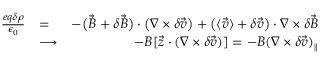Convert formula to latex. <formula><loc_0><loc_0><loc_500><loc_500>\begin{array} { r l r } { \frac { e q \delta \rho } { \epsilon _ { 0 } } } & { = } & { - \left ( \vec { B } + \delta \vec { B } \right ) \cdot \left ( \nabla \times \delta \vec { v } \right ) + \left ( \langle \vec { v } \rangle + \delta \vec { v } \right ) \cdot \nabla \times \delta \vec { B } } \\ & { \longrightarrow } & { \ - B [ \vec { z } \cdot ( \nabla \times \delta \vec { v } ) ] = - B ( \nabla \times \delta \vec { v } ) _ { \| } } \end{array}</formula> 